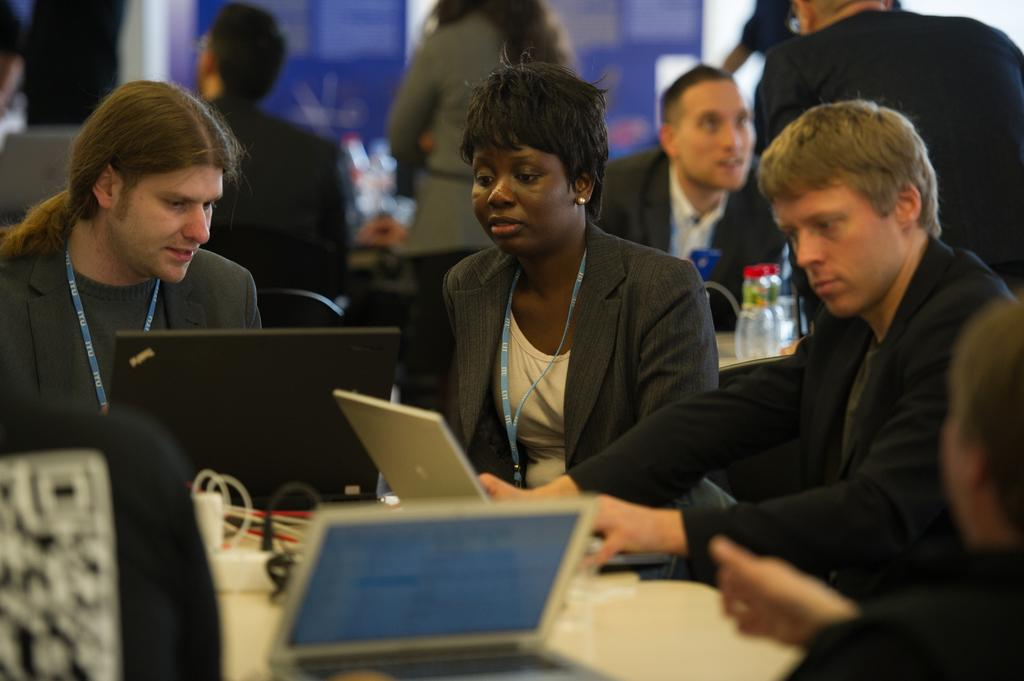What electronic devices are on the table in the image? There are laptops on the table in the image. What else can be seen on the table besides the laptops? There are cables on the table in the image. What are the people in the image doing? There are people sitting on chairs and people standing in the image. Can you describe the background of the image? The background of the image is blurred. What type of hand tool is the carpenter using in the image? There is no carpenter or hand tool present in the image. What kind of crack is visible on the laptop screen in the image? There is no crack visible on any laptop screen in the image. 